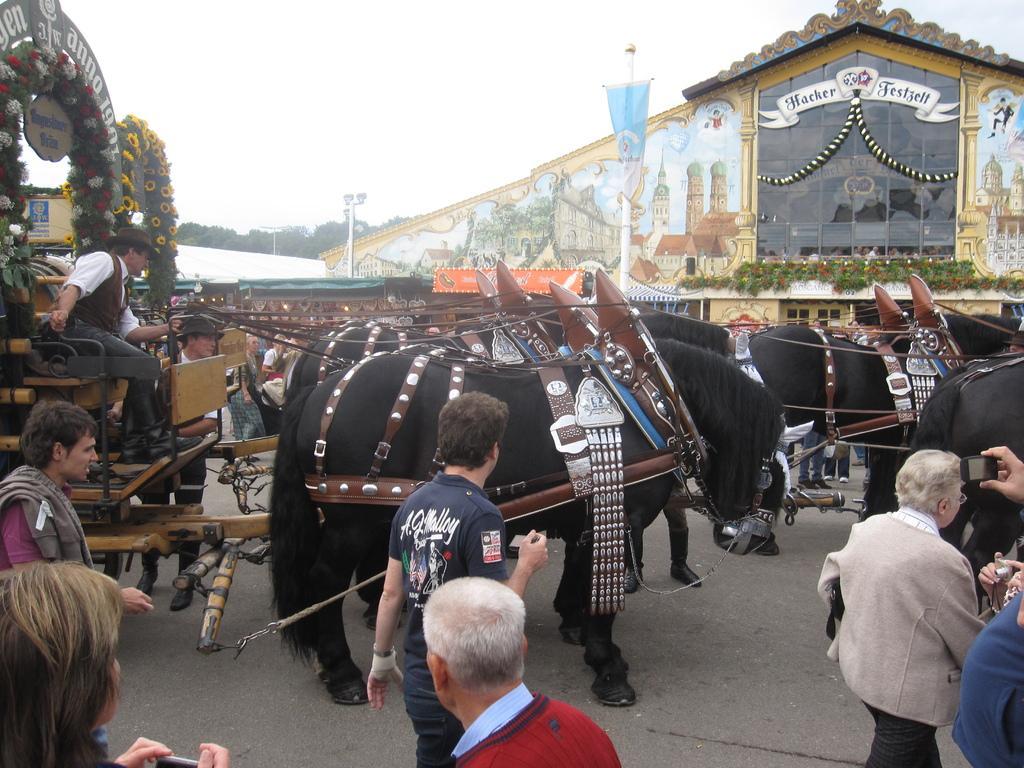Describe this image in one or two sentences. In this picture we can see animal carriages with people sitting on them. We can also see people walking on the road. 